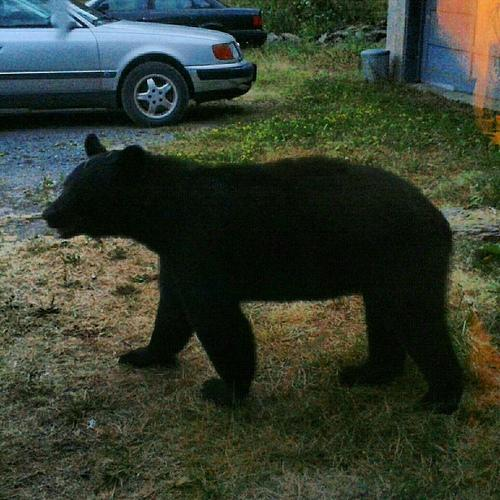What is the primary focus in the image and its action? The primary focus is a big black bear, walking across a lawn. Enumerate the two main parts of the bear that are visible and their respective dimensions. The two main parts are the head of the bear, with dimensions Width:97 Height:97 and the leg of the bear, with dimensions Width:105 Height:105. Can you identify the species and the activity of the main creature featured in this photo? The image features a black bear walking across a grassy area. Discuss the interaction between the black bear and its environment. The black bear walks across a lawn with a mix of green and yellow grass, surrounded by cars, a trash can, and a raised conical structure. Count the number of cars seen in the image and describe their general placement. There are two cars in the image; a silver car parked on gravel and a black four-door car parked. What type of vehicle is in the image and where is it placed? There is a silver car parked on gravel and a black four-door car parked as well. 